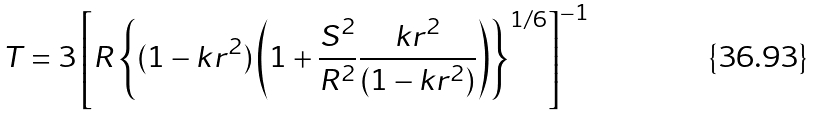Convert formula to latex. <formula><loc_0><loc_0><loc_500><loc_500>T = 3 \left [ R \left \{ ( 1 - k r ^ { 2 } ) \left ( 1 + \frac { S ^ { 2 } } { R ^ { 2 } } \frac { k r ^ { 2 } } { ( 1 - k r ^ { 2 } ) } \right ) \right \} ^ { 1 / 6 } \right ] ^ { - 1 }</formula> 